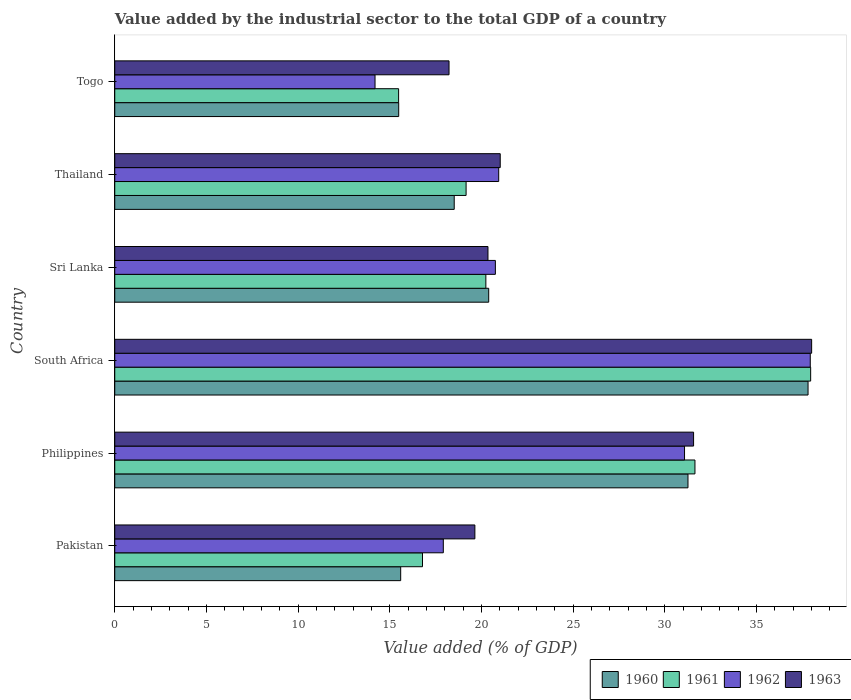How many different coloured bars are there?
Provide a short and direct response. 4. How many groups of bars are there?
Provide a short and direct response. 6. Are the number of bars per tick equal to the number of legend labels?
Your answer should be very brief. Yes. How many bars are there on the 6th tick from the bottom?
Give a very brief answer. 4. What is the value added by the industrial sector to the total GDP in 1962 in Pakistan?
Your response must be concise. 17.92. Across all countries, what is the maximum value added by the industrial sector to the total GDP in 1961?
Keep it short and to the point. 37.96. Across all countries, what is the minimum value added by the industrial sector to the total GDP in 1960?
Your response must be concise. 15.49. In which country was the value added by the industrial sector to the total GDP in 1960 maximum?
Your answer should be compact. South Africa. In which country was the value added by the industrial sector to the total GDP in 1961 minimum?
Offer a very short reply. Togo. What is the total value added by the industrial sector to the total GDP in 1963 in the graph?
Make the answer very short. 148.85. What is the difference between the value added by the industrial sector to the total GDP in 1960 in Philippines and that in Sri Lanka?
Offer a very short reply. 10.87. What is the difference between the value added by the industrial sector to the total GDP in 1962 in Philippines and the value added by the industrial sector to the total GDP in 1960 in Pakistan?
Your answer should be very brief. 15.48. What is the average value added by the industrial sector to the total GDP in 1962 per country?
Your response must be concise. 23.81. What is the difference between the value added by the industrial sector to the total GDP in 1963 and value added by the industrial sector to the total GDP in 1962 in Sri Lanka?
Keep it short and to the point. -0.4. What is the ratio of the value added by the industrial sector to the total GDP in 1962 in Philippines to that in South Africa?
Offer a terse response. 0.82. Is the value added by the industrial sector to the total GDP in 1961 in Pakistan less than that in Sri Lanka?
Offer a terse response. Yes. What is the difference between the highest and the second highest value added by the industrial sector to the total GDP in 1961?
Give a very brief answer. 6.31. What is the difference between the highest and the lowest value added by the industrial sector to the total GDP in 1960?
Your answer should be very brief. 22.33. In how many countries, is the value added by the industrial sector to the total GDP in 1961 greater than the average value added by the industrial sector to the total GDP in 1961 taken over all countries?
Your answer should be very brief. 2. Is the sum of the value added by the industrial sector to the total GDP in 1962 in Philippines and Togo greater than the maximum value added by the industrial sector to the total GDP in 1960 across all countries?
Your answer should be compact. Yes. Is it the case that in every country, the sum of the value added by the industrial sector to the total GDP in 1960 and value added by the industrial sector to the total GDP in 1961 is greater than the sum of value added by the industrial sector to the total GDP in 1962 and value added by the industrial sector to the total GDP in 1963?
Offer a very short reply. No. What does the 3rd bar from the top in Togo represents?
Your answer should be very brief. 1961. Is it the case that in every country, the sum of the value added by the industrial sector to the total GDP in 1962 and value added by the industrial sector to the total GDP in 1961 is greater than the value added by the industrial sector to the total GDP in 1963?
Provide a short and direct response. Yes. Are all the bars in the graph horizontal?
Your answer should be compact. Yes. How many countries are there in the graph?
Offer a very short reply. 6. Does the graph contain any zero values?
Make the answer very short. No. Does the graph contain grids?
Make the answer very short. No. How many legend labels are there?
Your answer should be compact. 4. How are the legend labels stacked?
Keep it short and to the point. Horizontal. What is the title of the graph?
Your answer should be compact. Value added by the industrial sector to the total GDP of a country. What is the label or title of the X-axis?
Your response must be concise. Value added (% of GDP). What is the label or title of the Y-axis?
Provide a short and direct response. Country. What is the Value added (% of GDP) of 1960 in Pakistan?
Give a very brief answer. 15.6. What is the Value added (% of GDP) in 1961 in Pakistan?
Your answer should be compact. 16.79. What is the Value added (% of GDP) in 1962 in Pakistan?
Your answer should be compact. 17.92. What is the Value added (% of GDP) of 1963 in Pakistan?
Your answer should be compact. 19.64. What is the Value added (% of GDP) of 1960 in Philippines?
Offer a terse response. 31.27. What is the Value added (% of GDP) of 1961 in Philippines?
Keep it short and to the point. 31.65. What is the Value added (% of GDP) in 1962 in Philippines?
Keep it short and to the point. 31.08. What is the Value added (% of GDP) of 1963 in Philippines?
Keep it short and to the point. 31.57. What is the Value added (% of GDP) in 1960 in South Africa?
Ensure brevity in your answer.  37.82. What is the Value added (% of GDP) in 1961 in South Africa?
Your response must be concise. 37.96. What is the Value added (% of GDP) of 1962 in South Africa?
Offer a very short reply. 37.94. What is the Value added (% of GDP) of 1963 in South Africa?
Keep it short and to the point. 38.01. What is the Value added (% of GDP) of 1960 in Sri Lanka?
Provide a short and direct response. 20.4. What is the Value added (% of GDP) of 1961 in Sri Lanka?
Offer a terse response. 20.24. What is the Value added (% of GDP) in 1962 in Sri Lanka?
Ensure brevity in your answer.  20.76. What is the Value added (% of GDP) in 1963 in Sri Lanka?
Ensure brevity in your answer.  20.36. What is the Value added (% of GDP) of 1960 in Thailand?
Give a very brief answer. 18.52. What is the Value added (% of GDP) in 1961 in Thailand?
Ensure brevity in your answer.  19.16. What is the Value added (% of GDP) of 1962 in Thailand?
Ensure brevity in your answer.  20.94. What is the Value added (% of GDP) in 1963 in Thailand?
Ensure brevity in your answer.  21.03. What is the Value added (% of GDP) in 1960 in Togo?
Keep it short and to the point. 15.49. What is the Value added (% of GDP) in 1961 in Togo?
Give a very brief answer. 15.48. What is the Value added (% of GDP) in 1962 in Togo?
Provide a succinct answer. 14.2. What is the Value added (% of GDP) of 1963 in Togo?
Provide a succinct answer. 18.23. Across all countries, what is the maximum Value added (% of GDP) of 1960?
Keep it short and to the point. 37.82. Across all countries, what is the maximum Value added (% of GDP) in 1961?
Give a very brief answer. 37.96. Across all countries, what is the maximum Value added (% of GDP) in 1962?
Your answer should be compact. 37.94. Across all countries, what is the maximum Value added (% of GDP) of 1963?
Your answer should be compact. 38.01. Across all countries, what is the minimum Value added (% of GDP) in 1960?
Your answer should be compact. 15.49. Across all countries, what is the minimum Value added (% of GDP) in 1961?
Give a very brief answer. 15.48. Across all countries, what is the minimum Value added (% of GDP) of 1962?
Your response must be concise. 14.2. Across all countries, what is the minimum Value added (% of GDP) in 1963?
Your answer should be compact. 18.23. What is the total Value added (% of GDP) of 1960 in the graph?
Your response must be concise. 139.09. What is the total Value added (% of GDP) in 1961 in the graph?
Your response must be concise. 141.29. What is the total Value added (% of GDP) of 1962 in the graph?
Your answer should be very brief. 142.84. What is the total Value added (% of GDP) of 1963 in the graph?
Provide a short and direct response. 148.85. What is the difference between the Value added (% of GDP) of 1960 in Pakistan and that in Philippines?
Provide a short and direct response. -15.67. What is the difference between the Value added (% of GDP) of 1961 in Pakistan and that in Philippines?
Give a very brief answer. -14.86. What is the difference between the Value added (% of GDP) in 1962 in Pakistan and that in Philippines?
Give a very brief answer. -13.16. What is the difference between the Value added (% of GDP) of 1963 in Pakistan and that in Philippines?
Offer a very short reply. -11.93. What is the difference between the Value added (% of GDP) in 1960 in Pakistan and that in South Africa?
Your answer should be very brief. -22.22. What is the difference between the Value added (% of GDP) in 1961 in Pakistan and that in South Africa?
Keep it short and to the point. -21.17. What is the difference between the Value added (% of GDP) in 1962 in Pakistan and that in South Africa?
Make the answer very short. -20.02. What is the difference between the Value added (% of GDP) of 1963 in Pakistan and that in South Africa?
Offer a very short reply. -18.37. What is the difference between the Value added (% of GDP) in 1960 in Pakistan and that in Sri Lanka?
Your answer should be compact. -4.8. What is the difference between the Value added (% of GDP) of 1961 in Pakistan and that in Sri Lanka?
Ensure brevity in your answer.  -3.46. What is the difference between the Value added (% of GDP) in 1962 in Pakistan and that in Sri Lanka?
Make the answer very short. -2.84. What is the difference between the Value added (% of GDP) of 1963 in Pakistan and that in Sri Lanka?
Provide a short and direct response. -0.71. What is the difference between the Value added (% of GDP) of 1960 in Pakistan and that in Thailand?
Your answer should be compact. -2.92. What is the difference between the Value added (% of GDP) of 1961 in Pakistan and that in Thailand?
Your response must be concise. -2.38. What is the difference between the Value added (% of GDP) of 1962 in Pakistan and that in Thailand?
Offer a very short reply. -3.02. What is the difference between the Value added (% of GDP) of 1963 in Pakistan and that in Thailand?
Make the answer very short. -1.38. What is the difference between the Value added (% of GDP) of 1960 in Pakistan and that in Togo?
Your answer should be very brief. 0.11. What is the difference between the Value added (% of GDP) in 1961 in Pakistan and that in Togo?
Your answer should be compact. 1.3. What is the difference between the Value added (% of GDP) of 1962 in Pakistan and that in Togo?
Ensure brevity in your answer.  3.72. What is the difference between the Value added (% of GDP) in 1963 in Pakistan and that in Togo?
Offer a terse response. 1.41. What is the difference between the Value added (% of GDP) in 1960 in Philippines and that in South Africa?
Ensure brevity in your answer.  -6.55. What is the difference between the Value added (% of GDP) of 1961 in Philippines and that in South Africa?
Offer a very short reply. -6.31. What is the difference between the Value added (% of GDP) in 1962 in Philippines and that in South Africa?
Ensure brevity in your answer.  -6.86. What is the difference between the Value added (% of GDP) of 1963 in Philippines and that in South Africa?
Your answer should be very brief. -6.44. What is the difference between the Value added (% of GDP) in 1960 in Philippines and that in Sri Lanka?
Offer a very short reply. 10.87. What is the difference between the Value added (% of GDP) of 1961 in Philippines and that in Sri Lanka?
Offer a terse response. 11.41. What is the difference between the Value added (% of GDP) of 1962 in Philippines and that in Sri Lanka?
Your response must be concise. 10.32. What is the difference between the Value added (% of GDP) of 1963 in Philippines and that in Sri Lanka?
Your response must be concise. 11.22. What is the difference between the Value added (% of GDP) in 1960 in Philippines and that in Thailand?
Offer a very short reply. 12.75. What is the difference between the Value added (% of GDP) of 1961 in Philippines and that in Thailand?
Your answer should be compact. 12.48. What is the difference between the Value added (% of GDP) of 1962 in Philippines and that in Thailand?
Your response must be concise. 10.14. What is the difference between the Value added (% of GDP) in 1963 in Philippines and that in Thailand?
Keep it short and to the point. 10.55. What is the difference between the Value added (% of GDP) of 1960 in Philippines and that in Togo?
Make the answer very short. 15.78. What is the difference between the Value added (% of GDP) in 1961 in Philippines and that in Togo?
Keep it short and to the point. 16.16. What is the difference between the Value added (% of GDP) in 1962 in Philippines and that in Togo?
Give a very brief answer. 16.88. What is the difference between the Value added (% of GDP) of 1963 in Philippines and that in Togo?
Offer a terse response. 13.34. What is the difference between the Value added (% of GDP) in 1960 in South Africa and that in Sri Lanka?
Your answer should be compact. 17.42. What is the difference between the Value added (% of GDP) in 1961 in South Africa and that in Sri Lanka?
Keep it short and to the point. 17.72. What is the difference between the Value added (% of GDP) in 1962 in South Africa and that in Sri Lanka?
Offer a terse response. 17.18. What is the difference between the Value added (% of GDP) in 1963 in South Africa and that in Sri Lanka?
Ensure brevity in your answer.  17.66. What is the difference between the Value added (% of GDP) of 1960 in South Africa and that in Thailand?
Make the answer very short. 19.3. What is the difference between the Value added (% of GDP) in 1961 in South Africa and that in Thailand?
Make the answer very short. 18.79. What is the difference between the Value added (% of GDP) in 1962 in South Africa and that in Thailand?
Your response must be concise. 17. What is the difference between the Value added (% of GDP) of 1963 in South Africa and that in Thailand?
Give a very brief answer. 16.99. What is the difference between the Value added (% of GDP) in 1960 in South Africa and that in Togo?
Give a very brief answer. 22.33. What is the difference between the Value added (% of GDP) in 1961 in South Africa and that in Togo?
Offer a terse response. 22.48. What is the difference between the Value added (% of GDP) in 1962 in South Africa and that in Togo?
Provide a short and direct response. 23.74. What is the difference between the Value added (% of GDP) of 1963 in South Africa and that in Togo?
Keep it short and to the point. 19.78. What is the difference between the Value added (% of GDP) of 1960 in Sri Lanka and that in Thailand?
Make the answer very short. 1.88. What is the difference between the Value added (% of GDP) in 1961 in Sri Lanka and that in Thailand?
Provide a short and direct response. 1.08. What is the difference between the Value added (% of GDP) of 1962 in Sri Lanka and that in Thailand?
Your response must be concise. -0.18. What is the difference between the Value added (% of GDP) of 1963 in Sri Lanka and that in Thailand?
Your answer should be compact. -0.67. What is the difference between the Value added (% of GDP) in 1960 in Sri Lanka and that in Togo?
Make the answer very short. 4.91. What is the difference between the Value added (% of GDP) in 1961 in Sri Lanka and that in Togo?
Give a very brief answer. 4.76. What is the difference between the Value added (% of GDP) of 1962 in Sri Lanka and that in Togo?
Your answer should be compact. 6.56. What is the difference between the Value added (% of GDP) in 1963 in Sri Lanka and that in Togo?
Offer a very short reply. 2.12. What is the difference between the Value added (% of GDP) of 1960 in Thailand and that in Togo?
Make the answer very short. 3.03. What is the difference between the Value added (% of GDP) in 1961 in Thailand and that in Togo?
Your answer should be compact. 3.68. What is the difference between the Value added (% of GDP) of 1962 in Thailand and that in Togo?
Offer a terse response. 6.75. What is the difference between the Value added (% of GDP) of 1963 in Thailand and that in Togo?
Provide a short and direct response. 2.79. What is the difference between the Value added (% of GDP) in 1960 in Pakistan and the Value added (% of GDP) in 1961 in Philippines?
Your response must be concise. -16.05. What is the difference between the Value added (% of GDP) in 1960 in Pakistan and the Value added (% of GDP) in 1962 in Philippines?
Keep it short and to the point. -15.48. What is the difference between the Value added (% of GDP) of 1960 in Pakistan and the Value added (% of GDP) of 1963 in Philippines?
Make the answer very short. -15.98. What is the difference between the Value added (% of GDP) of 1961 in Pakistan and the Value added (% of GDP) of 1962 in Philippines?
Your answer should be very brief. -14.29. What is the difference between the Value added (% of GDP) of 1961 in Pakistan and the Value added (% of GDP) of 1963 in Philippines?
Make the answer very short. -14.79. What is the difference between the Value added (% of GDP) of 1962 in Pakistan and the Value added (% of GDP) of 1963 in Philippines?
Your response must be concise. -13.65. What is the difference between the Value added (% of GDP) of 1960 in Pakistan and the Value added (% of GDP) of 1961 in South Africa?
Provide a short and direct response. -22.36. What is the difference between the Value added (% of GDP) of 1960 in Pakistan and the Value added (% of GDP) of 1962 in South Africa?
Your response must be concise. -22.34. What is the difference between the Value added (% of GDP) in 1960 in Pakistan and the Value added (% of GDP) in 1963 in South Africa?
Your response must be concise. -22.42. What is the difference between the Value added (% of GDP) in 1961 in Pakistan and the Value added (% of GDP) in 1962 in South Africa?
Your answer should be very brief. -21.15. What is the difference between the Value added (% of GDP) in 1961 in Pakistan and the Value added (% of GDP) in 1963 in South Africa?
Your answer should be compact. -21.23. What is the difference between the Value added (% of GDP) of 1962 in Pakistan and the Value added (% of GDP) of 1963 in South Africa?
Provide a succinct answer. -20.09. What is the difference between the Value added (% of GDP) of 1960 in Pakistan and the Value added (% of GDP) of 1961 in Sri Lanka?
Your answer should be compact. -4.65. What is the difference between the Value added (% of GDP) in 1960 in Pakistan and the Value added (% of GDP) in 1962 in Sri Lanka?
Offer a very short reply. -5.16. What is the difference between the Value added (% of GDP) in 1960 in Pakistan and the Value added (% of GDP) in 1963 in Sri Lanka?
Your answer should be compact. -4.76. What is the difference between the Value added (% of GDP) in 1961 in Pakistan and the Value added (% of GDP) in 1962 in Sri Lanka?
Your answer should be compact. -3.97. What is the difference between the Value added (% of GDP) of 1961 in Pakistan and the Value added (% of GDP) of 1963 in Sri Lanka?
Give a very brief answer. -3.57. What is the difference between the Value added (% of GDP) of 1962 in Pakistan and the Value added (% of GDP) of 1963 in Sri Lanka?
Make the answer very short. -2.44. What is the difference between the Value added (% of GDP) in 1960 in Pakistan and the Value added (% of GDP) in 1961 in Thailand?
Your answer should be compact. -3.57. What is the difference between the Value added (% of GDP) in 1960 in Pakistan and the Value added (% of GDP) in 1962 in Thailand?
Provide a succinct answer. -5.35. What is the difference between the Value added (% of GDP) in 1960 in Pakistan and the Value added (% of GDP) in 1963 in Thailand?
Provide a succinct answer. -5.43. What is the difference between the Value added (% of GDP) of 1961 in Pakistan and the Value added (% of GDP) of 1962 in Thailand?
Provide a short and direct response. -4.16. What is the difference between the Value added (% of GDP) in 1961 in Pakistan and the Value added (% of GDP) in 1963 in Thailand?
Keep it short and to the point. -4.24. What is the difference between the Value added (% of GDP) of 1962 in Pakistan and the Value added (% of GDP) of 1963 in Thailand?
Offer a very short reply. -3.11. What is the difference between the Value added (% of GDP) of 1960 in Pakistan and the Value added (% of GDP) of 1961 in Togo?
Your answer should be very brief. 0.11. What is the difference between the Value added (% of GDP) in 1960 in Pakistan and the Value added (% of GDP) in 1962 in Togo?
Your answer should be compact. 1.4. What is the difference between the Value added (% of GDP) of 1960 in Pakistan and the Value added (% of GDP) of 1963 in Togo?
Make the answer very short. -2.64. What is the difference between the Value added (% of GDP) in 1961 in Pakistan and the Value added (% of GDP) in 1962 in Togo?
Your response must be concise. 2.59. What is the difference between the Value added (% of GDP) in 1961 in Pakistan and the Value added (% of GDP) in 1963 in Togo?
Provide a short and direct response. -1.45. What is the difference between the Value added (% of GDP) of 1962 in Pakistan and the Value added (% of GDP) of 1963 in Togo?
Give a very brief answer. -0.31. What is the difference between the Value added (% of GDP) of 1960 in Philippines and the Value added (% of GDP) of 1961 in South Africa?
Your response must be concise. -6.69. What is the difference between the Value added (% of GDP) of 1960 in Philippines and the Value added (% of GDP) of 1962 in South Africa?
Make the answer very short. -6.67. What is the difference between the Value added (% of GDP) in 1960 in Philippines and the Value added (% of GDP) in 1963 in South Africa?
Keep it short and to the point. -6.75. What is the difference between the Value added (% of GDP) in 1961 in Philippines and the Value added (% of GDP) in 1962 in South Africa?
Your answer should be compact. -6.29. What is the difference between the Value added (% of GDP) of 1961 in Philippines and the Value added (% of GDP) of 1963 in South Africa?
Keep it short and to the point. -6.37. What is the difference between the Value added (% of GDP) of 1962 in Philippines and the Value added (% of GDP) of 1963 in South Africa?
Your answer should be very brief. -6.93. What is the difference between the Value added (% of GDP) in 1960 in Philippines and the Value added (% of GDP) in 1961 in Sri Lanka?
Offer a very short reply. 11.03. What is the difference between the Value added (% of GDP) of 1960 in Philippines and the Value added (% of GDP) of 1962 in Sri Lanka?
Your answer should be compact. 10.51. What is the difference between the Value added (% of GDP) of 1960 in Philippines and the Value added (% of GDP) of 1963 in Sri Lanka?
Provide a succinct answer. 10.91. What is the difference between the Value added (% of GDP) in 1961 in Philippines and the Value added (% of GDP) in 1962 in Sri Lanka?
Keep it short and to the point. 10.89. What is the difference between the Value added (% of GDP) of 1961 in Philippines and the Value added (% of GDP) of 1963 in Sri Lanka?
Provide a succinct answer. 11.29. What is the difference between the Value added (% of GDP) of 1962 in Philippines and the Value added (% of GDP) of 1963 in Sri Lanka?
Your answer should be very brief. 10.72. What is the difference between the Value added (% of GDP) of 1960 in Philippines and the Value added (% of GDP) of 1961 in Thailand?
Your response must be concise. 12.1. What is the difference between the Value added (% of GDP) of 1960 in Philippines and the Value added (% of GDP) of 1962 in Thailand?
Provide a succinct answer. 10.33. What is the difference between the Value added (% of GDP) of 1960 in Philippines and the Value added (% of GDP) of 1963 in Thailand?
Make the answer very short. 10.24. What is the difference between the Value added (% of GDP) of 1961 in Philippines and the Value added (% of GDP) of 1962 in Thailand?
Provide a succinct answer. 10.71. What is the difference between the Value added (% of GDP) of 1961 in Philippines and the Value added (% of GDP) of 1963 in Thailand?
Offer a very short reply. 10.62. What is the difference between the Value added (% of GDP) of 1962 in Philippines and the Value added (% of GDP) of 1963 in Thailand?
Provide a succinct answer. 10.05. What is the difference between the Value added (% of GDP) of 1960 in Philippines and the Value added (% of GDP) of 1961 in Togo?
Provide a succinct answer. 15.78. What is the difference between the Value added (% of GDP) in 1960 in Philippines and the Value added (% of GDP) in 1962 in Togo?
Provide a short and direct response. 17.07. What is the difference between the Value added (% of GDP) of 1960 in Philippines and the Value added (% of GDP) of 1963 in Togo?
Give a very brief answer. 13.03. What is the difference between the Value added (% of GDP) in 1961 in Philippines and the Value added (% of GDP) in 1962 in Togo?
Your response must be concise. 17.45. What is the difference between the Value added (% of GDP) of 1961 in Philippines and the Value added (% of GDP) of 1963 in Togo?
Keep it short and to the point. 13.41. What is the difference between the Value added (% of GDP) of 1962 in Philippines and the Value added (% of GDP) of 1963 in Togo?
Your answer should be very brief. 12.85. What is the difference between the Value added (% of GDP) of 1960 in South Africa and the Value added (% of GDP) of 1961 in Sri Lanka?
Ensure brevity in your answer.  17.57. What is the difference between the Value added (% of GDP) in 1960 in South Africa and the Value added (% of GDP) in 1962 in Sri Lanka?
Offer a terse response. 17.06. What is the difference between the Value added (% of GDP) of 1960 in South Africa and the Value added (% of GDP) of 1963 in Sri Lanka?
Make the answer very short. 17.46. What is the difference between the Value added (% of GDP) of 1961 in South Africa and the Value added (% of GDP) of 1962 in Sri Lanka?
Provide a succinct answer. 17.2. What is the difference between the Value added (% of GDP) in 1961 in South Africa and the Value added (% of GDP) in 1963 in Sri Lanka?
Offer a terse response. 17.6. What is the difference between the Value added (% of GDP) of 1962 in South Africa and the Value added (% of GDP) of 1963 in Sri Lanka?
Your answer should be very brief. 17.58. What is the difference between the Value added (% of GDP) in 1960 in South Africa and the Value added (% of GDP) in 1961 in Thailand?
Make the answer very short. 18.65. What is the difference between the Value added (% of GDP) of 1960 in South Africa and the Value added (% of GDP) of 1962 in Thailand?
Offer a very short reply. 16.87. What is the difference between the Value added (% of GDP) in 1960 in South Africa and the Value added (% of GDP) in 1963 in Thailand?
Provide a short and direct response. 16.79. What is the difference between the Value added (% of GDP) of 1961 in South Africa and the Value added (% of GDP) of 1962 in Thailand?
Give a very brief answer. 17.02. What is the difference between the Value added (% of GDP) of 1961 in South Africa and the Value added (% of GDP) of 1963 in Thailand?
Make the answer very short. 16.93. What is the difference between the Value added (% of GDP) in 1962 in South Africa and the Value added (% of GDP) in 1963 in Thailand?
Your response must be concise. 16.91. What is the difference between the Value added (% of GDP) in 1960 in South Africa and the Value added (% of GDP) in 1961 in Togo?
Offer a very short reply. 22.33. What is the difference between the Value added (% of GDP) in 1960 in South Africa and the Value added (% of GDP) in 1962 in Togo?
Your answer should be compact. 23.62. What is the difference between the Value added (% of GDP) in 1960 in South Africa and the Value added (% of GDP) in 1963 in Togo?
Offer a terse response. 19.58. What is the difference between the Value added (% of GDP) in 1961 in South Africa and the Value added (% of GDP) in 1962 in Togo?
Your answer should be very brief. 23.76. What is the difference between the Value added (% of GDP) in 1961 in South Africa and the Value added (% of GDP) in 1963 in Togo?
Make the answer very short. 19.73. What is the difference between the Value added (% of GDP) of 1962 in South Africa and the Value added (% of GDP) of 1963 in Togo?
Your answer should be compact. 19.7. What is the difference between the Value added (% of GDP) of 1960 in Sri Lanka and the Value added (% of GDP) of 1961 in Thailand?
Offer a terse response. 1.23. What is the difference between the Value added (% of GDP) in 1960 in Sri Lanka and the Value added (% of GDP) in 1962 in Thailand?
Ensure brevity in your answer.  -0.54. What is the difference between the Value added (% of GDP) in 1960 in Sri Lanka and the Value added (% of GDP) in 1963 in Thailand?
Your answer should be very brief. -0.63. What is the difference between the Value added (% of GDP) of 1961 in Sri Lanka and the Value added (% of GDP) of 1962 in Thailand?
Offer a terse response. -0.7. What is the difference between the Value added (% of GDP) of 1961 in Sri Lanka and the Value added (% of GDP) of 1963 in Thailand?
Offer a terse response. -0.78. What is the difference between the Value added (% of GDP) in 1962 in Sri Lanka and the Value added (% of GDP) in 1963 in Thailand?
Offer a very short reply. -0.27. What is the difference between the Value added (% of GDP) of 1960 in Sri Lanka and the Value added (% of GDP) of 1961 in Togo?
Keep it short and to the point. 4.91. What is the difference between the Value added (% of GDP) of 1960 in Sri Lanka and the Value added (% of GDP) of 1962 in Togo?
Your response must be concise. 6.2. What is the difference between the Value added (% of GDP) of 1960 in Sri Lanka and the Value added (% of GDP) of 1963 in Togo?
Your answer should be very brief. 2.16. What is the difference between the Value added (% of GDP) of 1961 in Sri Lanka and the Value added (% of GDP) of 1962 in Togo?
Give a very brief answer. 6.05. What is the difference between the Value added (% of GDP) of 1961 in Sri Lanka and the Value added (% of GDP) of 1963 in Togo?
Give a very brief answer. 2.01. What is the difference between the Value added (% of GDP) of 1962 in Sri Lanka and the Value added (% of GDP) of 1963 in Togo?
Provide a succinct answer. 2.53. What is the difference between the Value added (% of GDP) in 1960 in Thailand and the Value added (% of GDP) in 1961 in Togo?
Offer a very short reply. 3.03. What is the difference between the Value added (% of GDP) in 1960 in Thailand and the Value added (% of GDP) in 1962 in Togo?
Your answer should be very brief. 4.32. What is the difference between the Value added (% of GDP) of 1960 in Thailand and the Value added (% of GDP) of 1963 in Togo?
Your answer should be very brief. 0.28. What is the difference between the Value added (% of GDP) of 1961 in Thailand and the Value added (% of GDP) of 1962 in Togo?
Your answer should be very brief. 4.97. What is the difference between the Value added (% of GDP) in 1961 in Thailand and the Value added (% of GDP) in 1963 in Togo?
Make the answer very short. 0.93. What is the difference between the Value added (% of GDP) of 1962 in Thailand and the Value added (% of GDP) of 1963 in Togo?
Offer a terse response. 2.71. What is the average Value added (% of GDP) in 1960 per country?
Offer a very short reply. 23.18. What is the average Value added (% of GDP) of 1961 per country?
Your answer should be compact. 23.55. What is the average Value added (% of GDP) in 1962 per country?
Your answer should be compact. 23.81. What is the average Value added (% of GDP) of 1963 per country?
Give a very brief answer. 24.81. What is the difference between the Value added (% of GDP) in 1960 and Value added (% of GDP) in 1961 in Pakistan?
Your response must be concise. -1.19. What is the difference between the Value added (% of GDP) in 1960 and Value added (% of GDP) in 1962 in Pakistan?
Provide a succinct answer. -2.33. What is the difference between the Value added (% of GDP) in 1960 and Value added (% of GDP) in 1963 in Pakistan?
Give a very brief answer. -4.05. What is the difference between the Value added (% of GDP) in 1961 and Value added (% of GDP) in 1962 in Pakistan?
Your answer should be compact. -1.14. What is the difference between the Value added (% of GDP) of 1961 and Value added (% of GDP) of 1963 in Pakistan?
Your answer should be compact. -2.86. What is the difference between the Value added (% of GDP) of 1962 and Value added (% of GDP) of 1963 in Pakistan?
Keep it short and to the point. -1.72. What is the difference between the Value added (% of GDP) of 1960 and Value added (% of GDP) of 1961 in Philippines?
Keep it short and to the point. -0.38. What is the difference between the Value added (% of GDP) of 1960 and Value added (% of GDP) of 1962 in Philippines?
Provide a succinct answer. 0.19. What is the difference between the Value added (% of GDP) in 1960 and Value added (% of GDP) in 1963 in Philippines?
Offer a terse response. -0.3. What is the difference between the Value added (% of GDP) of 1961 and Value added (% of GDP) of 1962 in Philippines?
Offer a terse response. 0.57. What is the difference between the Value added (% of GDP) in 1961 and Value added (% of GDP) in 1963 in Philippines?
Ensure brevity in your answer.  0.08. What is the difference between the Value added (% of GDP) of 1962 and Value added (% of GDP) of 1963 in Philippines?
Offer a terse response. -0.49. What is the difference between the Value added (% of GDP) in 1960 and Value added (% of GDP) in 1961 in South Africa?
Give a very brief answer. -0.14. What is the difference between the Value added (% of GDP) in 1960 and Value added (% of GDP) in 1962 in South Africa?
Provide a succinct answer. -0.12. What is the difference between the Value added (% of GDP) in 1960 and Value added (% of GDP) in 1963 in South Africa?
Offer a very short reply. -0.2. What is the difference between the Value added (% of GDP) in 1961 and Value added (% of GDP) in 1962 in South Africa?
Your answer should be compact. 0.02. What is the difference between the Value added (% of GDP) of 1961 and Value added (% of GDP) of 1963 in South Africa?
Keep it short and to the point. -0.05. What is the difference between the Value added (% of GDP) in 1962 and Value added (% of GDP) in 1963 in South Africa?
Give a very brief answer. -0.08. What is the difference between the Value added (% of GDP) in 1960 and Value added (% of GDP) in 1961 in Sri Lanka?
Make the answer very short. 0.16. What is the difference between the Value added (% of GDP) of 1960 and Value added (% of GDP) of 1962 in Sri Lanka?
Provide a succinct answer. -0.36. What is the difference between the Value added (% of GDP) in 1960 and Value added (% of GDP) in 1963 in Sri Lanka?
Provide a short and direct response. 0.04. What is the difference between the Value added (% of GDP) in 1961 and Value added (% of GDP) in 1962 in Sri Lanka?
Your answer should be compact. -0.52. What is the difference between the Value added (% of GDP) in 1961 and Value added (% of GDP) in 1963 in Sri Lanka?
Your answer should be very brief. -0.11. What is the difference between the Value added (% of GDP) of 1962 and Value added (% of GDP) of 1963 in Sri Lanka?
Ensure brevity in your answer.  0.4. What is the difference between the Value added (% of GDP) in 1960 and Value added (% of GDP) in 1961 in Thailand?
Offer a very short reply. -0.65. What is the difference between the Value added (% of GDP) in 1960 and Value added (% of GDP) in 1962 in Thailand?
Make the answer very short. -2.43. What is the difference between the Value added (% of GDP) of 1960 and Value added (% of GDP) of 1963 in Thailand?
Make the answer very short. -2.51. What is the difference between the Value added (% of GDP) of 1961 and Value added (% of GDP) of 1962 in Thailand?
Your answer should be very brief. -1.78. What is the difference between the Value added (% of GDP) in 1961 and Value added (% of GDP) in 1963 in Thailand?
Make the answer very short. -1.86. What is the difference between the Value added (% of GDP) of 1962 and Value added (% of GDP) of 1963 in Thailand?
Provide a succinct answer. -0.08. What is the difference between the Value added (% of GDP) of 1960 and Value added (% of GDP) of 1961 in Togo?
Give a very brief answer. 0. What is the difference between the Value added (% of GDP) in 1960 and Value added (% of GDP) in 1962 in Togo?
Ensure brevity in your answer.  1.29. What is the difference between the Value added (% of GDP) of 1960 and Value added (% of GDP) of 1963 in Togo?
Provide a succinct answer. -2.75. What is the difference between the Value added (% of GDP) of 1961 and Value added (% of GDP) of 1962 in Togo?
Provide a succinct answer. 1.29. What is the difference between the Value added (% of GDP) in 1961 and Value added (% of GDP) in 1963 in Togo?
Ensure brevity in your answer.  -2.75. What is the difference between the Value added (% of GDP) in 1962 and Value added (% of GDP) in 1963 in Togo?
Ensure brevity in your answer.  -4.04. What is the ratio of the Value added (% of GDP) of 1960 in Pakistan to that in Philippines?
Give a very brief answer. 0.5. What is the ratio of the Value added (% of GDP) of 1961 in Pakistan to that in Philippines?
Ensure brevity in your answer.  0.53. What is the ratio of the Value added (% of GDP) of 1962 in Pakistan to that in Philippines?
Provide a succinct answer. 0.58. What is the ratio of the Value added (% of GDP) of 1963 in Pakistan to that in Philippines?
Your answer should be very brief. 0.62. What is the ratio of the Value added (% of GDP) in 1960 in Pakistan to that in South Africa?
Make the answer very short. 0.41. What is the ratio of the Value added (% of GDP) of 1961 in Pakistan to that in South Africa?
Keep it short and to the point. 0.44. What is the ratio of the Value added (% of GDP) in 1962 in Pakistan to that in South Africa?
Your response must be concise. 0.47. What is the ratio of the Value added (% of GDP) of 1963 in Pakistan to that in South Africa?
Ensure brevity in your answer.  0.52. What is the ratio of the Value added (% of GDP) in 1960 in Pakistan to that in Sri Lanka?
Keep it short and to the point. 0.76. What is the ratio of the Value added (% of GDP) in 1961 in Pakistan to that in Sri Lanka?
Offer a terse response. 0.83. What is the ratio of the Value added (% of GDP) in 1962 in Pakistan to that in Sri Lanka?
Your answer should be very brief. 0.86. What is the ratio of the Value added (% of GDP) of 1963 in Pakistan to that in Sri Lanka?
Offer a very short reply. 0.96. What is the ratio of the Value added (% of GDP) of 1960 in Pakistan to that in Thailand?
Give a very brief answer. 0.84. What is the ratio of the Value added (% of GDP) in 1961 in Pakistan to that in Thailand?
Give a very brief answer. 0.88. What is the ratio of the Value added (% of GDP) of 1962 in Pakistan to that in Thailand?
Keep it short and to the point. 0.86. What is the ratio of the Value added (% of GDP) in 1963 in Pakistan to that in Thailand?
Keep it short and to the point. 0.93. What is the ratio of the Value added (% of GDP) in 1961 in Pakistan to that in Togo?
Your answer should be compact. 1.08. What is the ratio of the Value added (% of GDP) in 1962 in Pakistan to that in Togo?
Your answer should be compact. 1.26. What is the ratio of the Value added (% of GDP) in 1963 in Pakistan to that in Togo?
Provide a short and direct response. 1.08. What is the ratio of the Value added (% of GDP) in 1960 in Philippines to that in South Africa?
Offer a very short reply. 0.83. What is the ratio of the Value added (% of GDP) of 1961 in Philippines to that in South Africa?
Keep it short and to the point. 0.83. What is the ratio of the Value added (% of GDP) of 1962 in Philippines to that in South Africa?
Your answer should be compact. 0.82. What is the ratio of the Value added (% of GDP) in 1963 in Philippines to that in South Africa?
Ensure brevity in your answer.  0.83. What is the ratio of the Value added (% of GDP) in 1960 in Philippines to that in Sri Lanka?
Your response must be concise. 1.53. What is the ratio of the Value added (% of GDP) of 1961 in Philippines to that in Sri Lanka?
Provide a succinct answer. 1.56. What is the ratio of the Value added (% of GDP) in 1962 in Philippines to that in Sri Lanka?
Offer a terse response. 1.5. What is the ratio of the Value added (% of GDP) of 1963 in Philippines to that in Sri Lanka?
Keep it short and to the point. 1.55. What is the ratio of the Value added (% of GDP) of 1960 in Philippines to that in Thailand?
Give a very brief answer. 1.69. What is the ratio of the Value added (% of GDP) in 1961 in Philippines to that in Thailand?
Your answer should be compact. 1.65. What is the ratio of the Value added (% of GDP) in 1962 in Philippines to that in Thailand?
Make the answer very short. 1.48. What is the ratio of the Value added (% of GDP) in 1963 in Philippines to that in Thailand?
Give a very brief answer. 1.5. What is the ratio of the Value added (% of GDP) in 1960 in Philippines to that in Togo?
Give a very brief answer. 2.02. What is the ratio of the Value added (% of GDP) in 1961 in Philippines to that in Togo?
Ensure brevity in your answer.  2.04. What is the ratio of the Value added (% of GDP) in 1962 in Philippines to that in Togo?
Make the answer very short. 2.19. What is the ratio of the Value added (% of GDP) in 1963 in Philippines to that in Togo?
Offer a terse response. 1.73. What is the ratio of the Value added (% of GDP) in 1960 in South Africa to that in Sri Lanka?
Provide a succinct answer. 1.85. What is the ratio of the Value added (% of GDP) in 1961 in South Africa to that in Sri Lanka?
Make the answer very short. 1.88. What is the ratio of the Value added (% of GDP) of 1962 in South Africa to that in Sri Lanka?
Give a very brief answer. 1.83. What is the ratio of the Value added (% of GDP) in 1963 in South Africa to that in Sri Lanka?
Your answer should be compact. 1.87. What is the ratio of the Value added (% of GDP) of 1960 in South Africa to that in Thailand?
Give a very brief answer. 2.04. What is the ratio of the Value added (% of GDP) of 1961 in South Africa to that in Thailand?
Provide a short and direct response. 1.98. What is the ratio of the Value added (% of GDP) of 1962 in South Africa to that in Thailand?
Your answer should be very brief. 1.81. What is the ratio of the Value added (% of GDP) of 1963 in South Africa to that in Thailand?
Offer a very short reply. 1.81. What is the ratio of the Value added (% of GDP) in 1960 in South Africa to that in Togo?
Offer a very short reply. 2.44. What is the ratio of the Value added (% of GDP) in 1961 in South Africa to that in Togo?
Provide a short and direct response. 2.45. What is the ratio of the Value added (% of GDP) in 1962 in South Africa to that in Togo?
Offer a very short reply. 2.67. What is the ratio of the Value added (% of GDP) of 1963 in South Africa to that in Togo?
Your answer should be very brief. 2.08. What is the ratio of the Value added (% of GDP) of 1960 in Sri Lanka to that in Thailand?
Provide a short and direct response. 1.1. What is the ratio of the Value added (% of GDP) of 1961 in Sri Lanka to that in Thailand?
Provide a succinct answer. 1.06. What is the ratio of the Value added (% of GDP) of 1963 in Sri Lanka to that in Thailand?
Provide a short and direct response. 0.97. What is the ratio of the Value added (% of GDP) of 1960 in Sri Lanka to that in Togo?
Your answer should be very brief. 1.32. What is the ratio of the Value added (% of GDP) of 1961 in Sri Lanka to that in Togo?
Your answer should be very brief. 1.31. What is the ratio of the Value added (% of GDP) in 1962 in Sri Lanka to that in Togo?
Offer a very short reply. 1.46. What is the ratio of the Value added (% of GDP) of 1963 in Sri Lanka to that in Togo?
Give a very brief answer. 1.12. What is the ratio of the Value added (% of GDP) of 1960 in Thailand to that in Togo?
Your answer should be compact. 1.2. What is the ratio of the Value added (% of GDP) of 1961 in Thailand to that in Togo?
Provide a succinct answer. 1.24. What is the ratio of the Value added (% of GDP) in 1962 in Thailand to that in Togo?
Your response must be concise. 1.48. What is the ratio of the Value added (% of GDP) of 1963 in Thailand to that in Togo?
Make the answer very short. 1.15. What is the difference between the highest and the second highest Value added (% of GDP) of 1960?
Your answer should be very brief. 6.55. What is the difference between the highest and the second highest Value added (% of GDP) in 1961?
Give a very brief answer. 6.31. What is the difference between the highest and the second highest Value added (% of GDP) in 1962?
Offer a terse response. 6.86. What is the difference between the highest and the second highest Value added (% of GDP) in 1963?
Give a very brief answer. 6.44. What is the difference between the highest and the lowest Value added (% of GDP) in 1960?
Ensure brevity in your answer.  22.33. What is the difference between the highest and the lowest Value added (% of GDP) in 1961?
Provide a short and direct response. 22.48. What is the difference between the highest and the lowest Value added (% of GDP) of 1962?
Provide a short and direct response. 23.74. What is the difference between the highest and the lowest Value added (% of GDP) of 1963?
Ensure brevity in your answer.  19.78. 